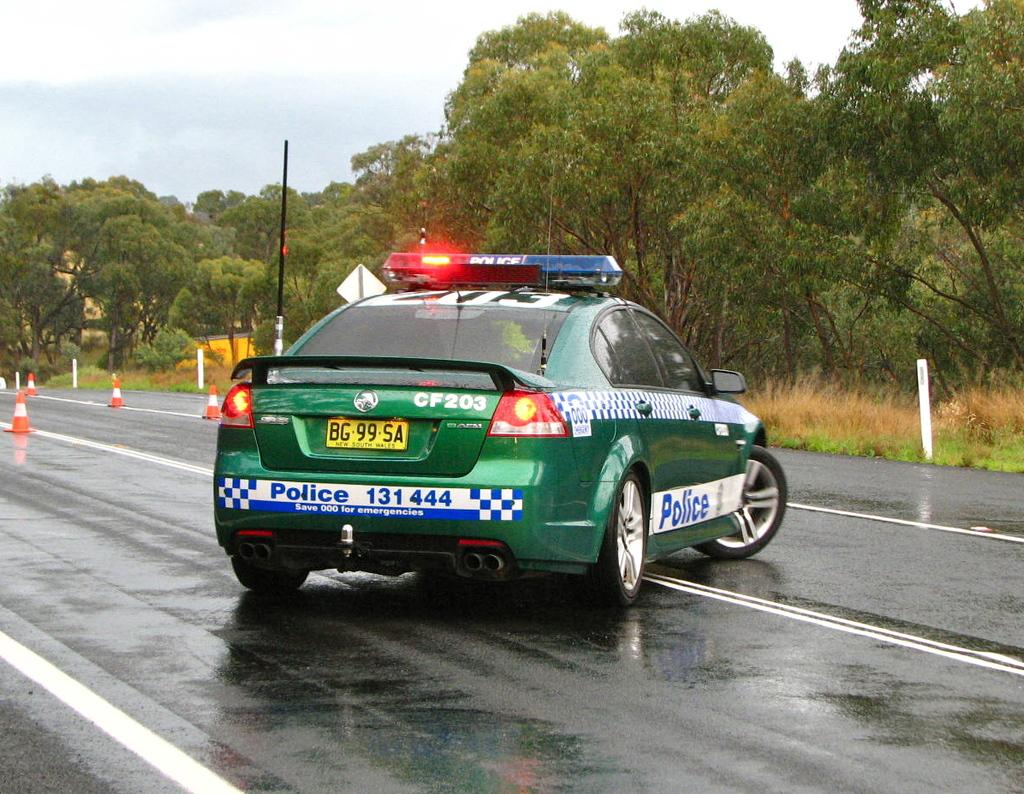What is the main subject of the image? There is a vehicle in the image. Can you describe the color of the vehicle? The vehicle is green. What can be seen in the background of the image? There are poles and trees in the background of the image. What is the color of the trees? The trees are green. What is visible above the trees in the image? The sky is visible in the background of the image. How would you describe the color of the sky? The sky is white. How many cows are grazing in the background of the image? There are no cows present in the image; it features a green vehicle, poles, trees, and a white sky. What type of death is depicted in the image? There is no depiction of death in the image; it is a scene with a vehicle, poles, trees, and a white sky. 